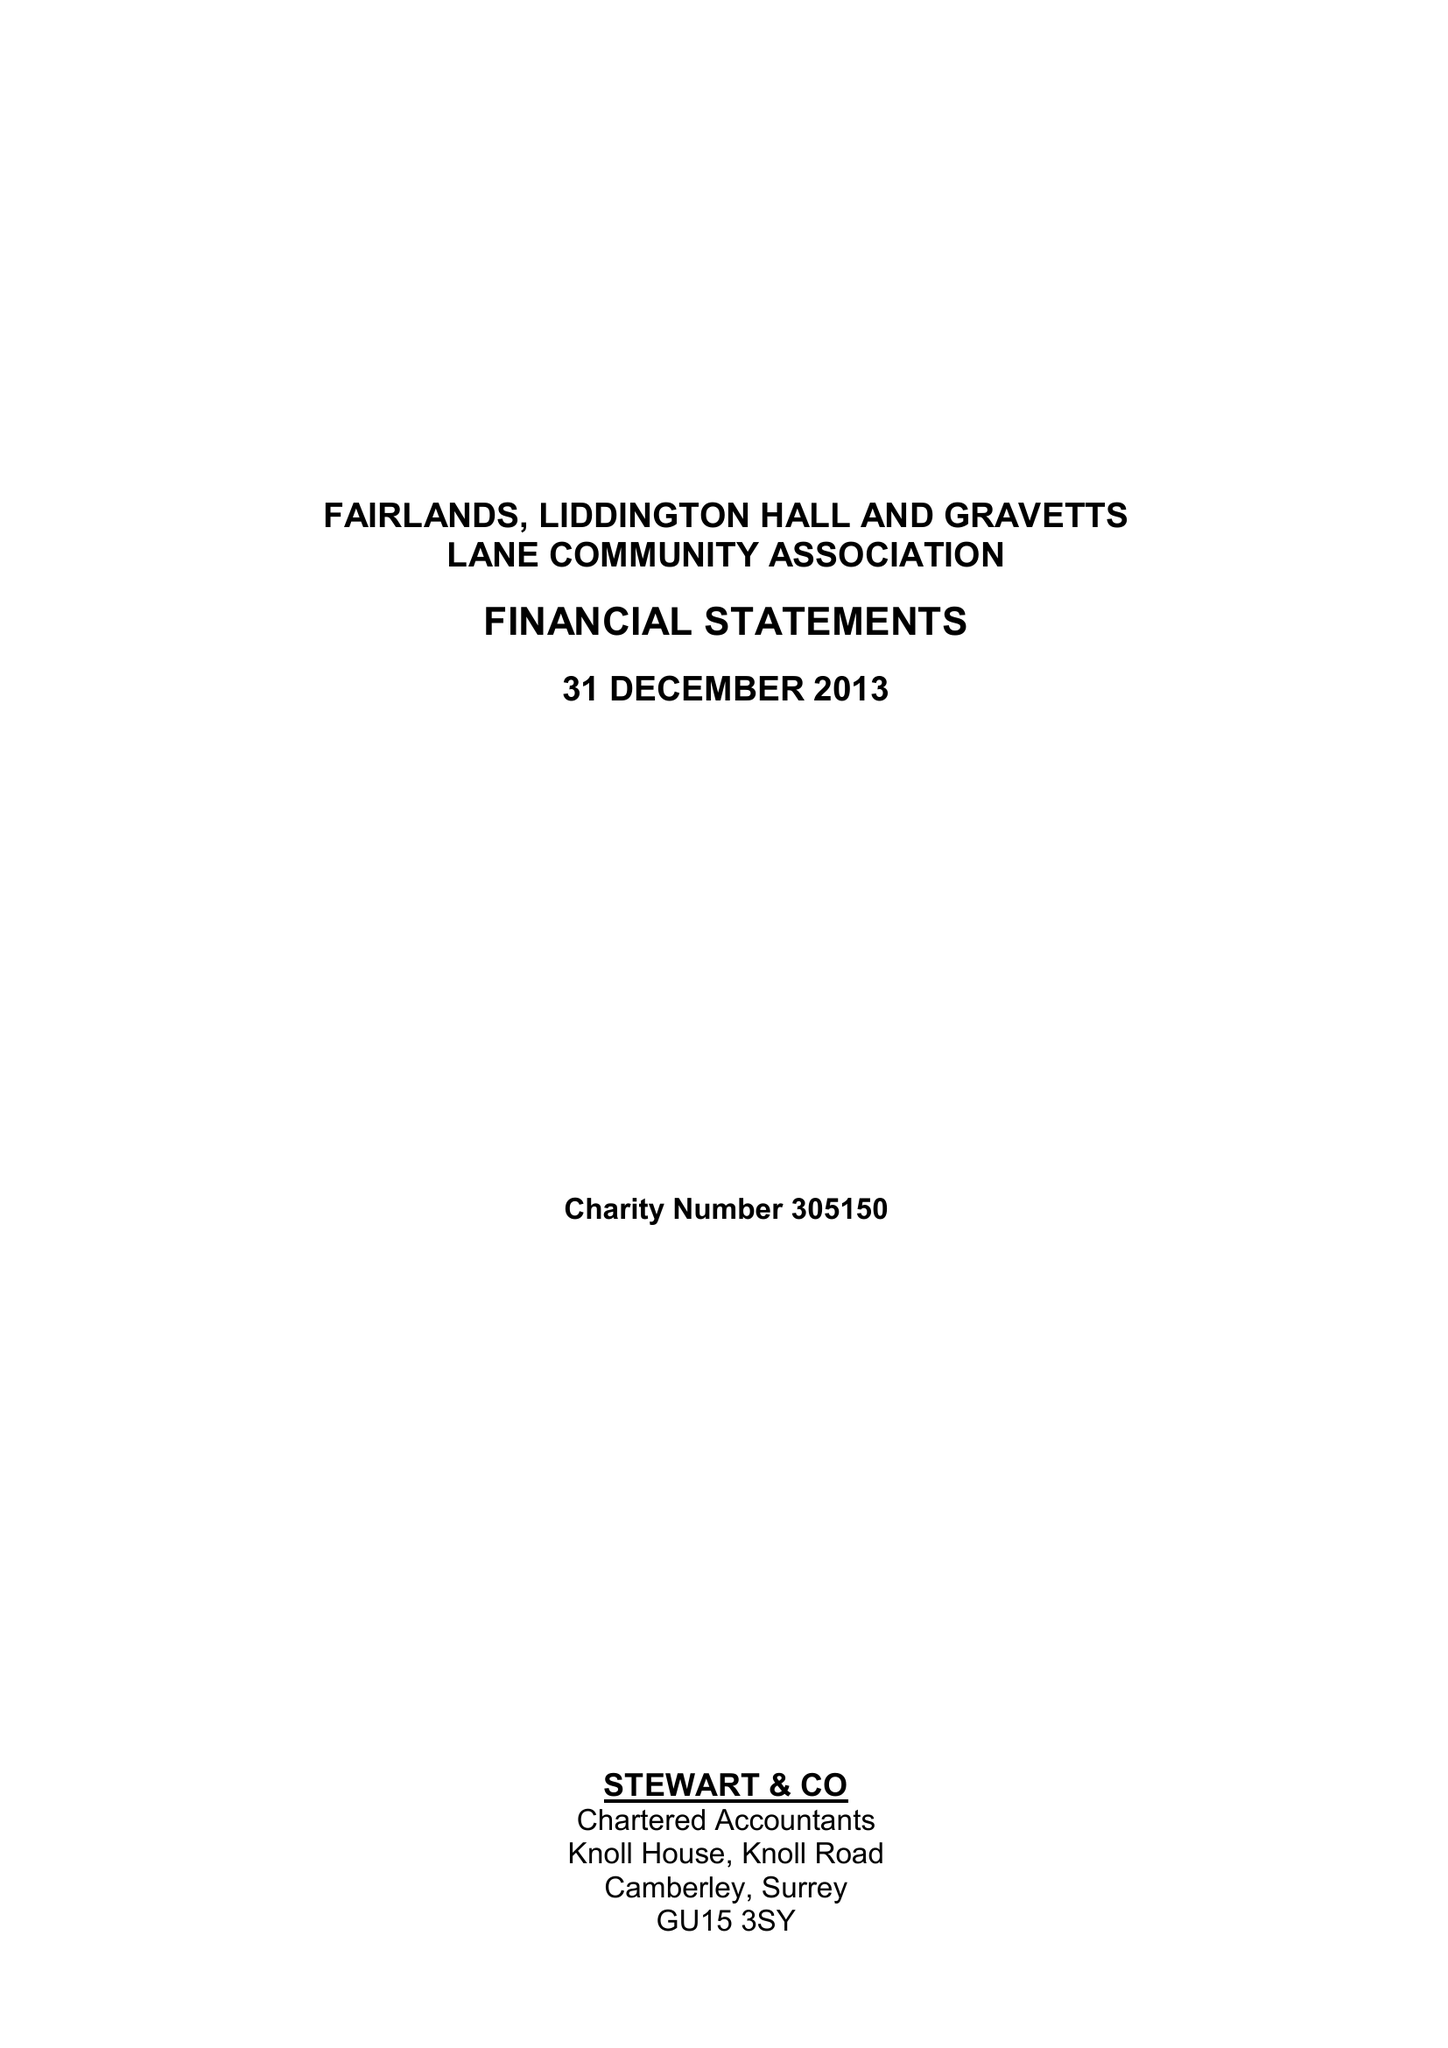What is the value for the address__post_town?
Answer the question using a single word or phrase. GUILDFORD 